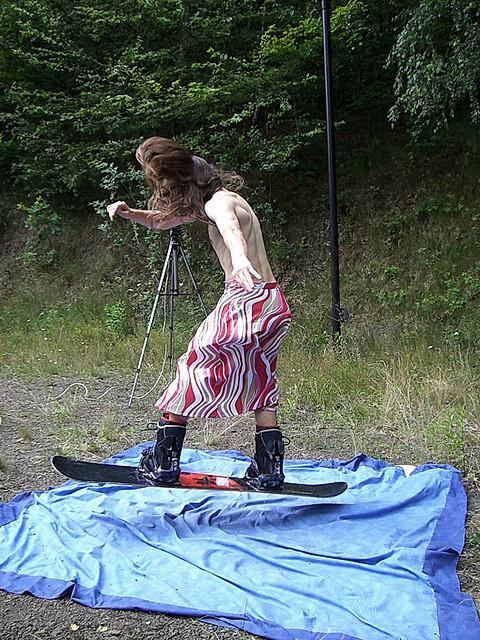What color is the blanket that is laying on the ground?
Quick response, please. Blue. Where is the tripod?
Quick response, please. Behind man. What color is the grass?
Answer briefly. Green. 